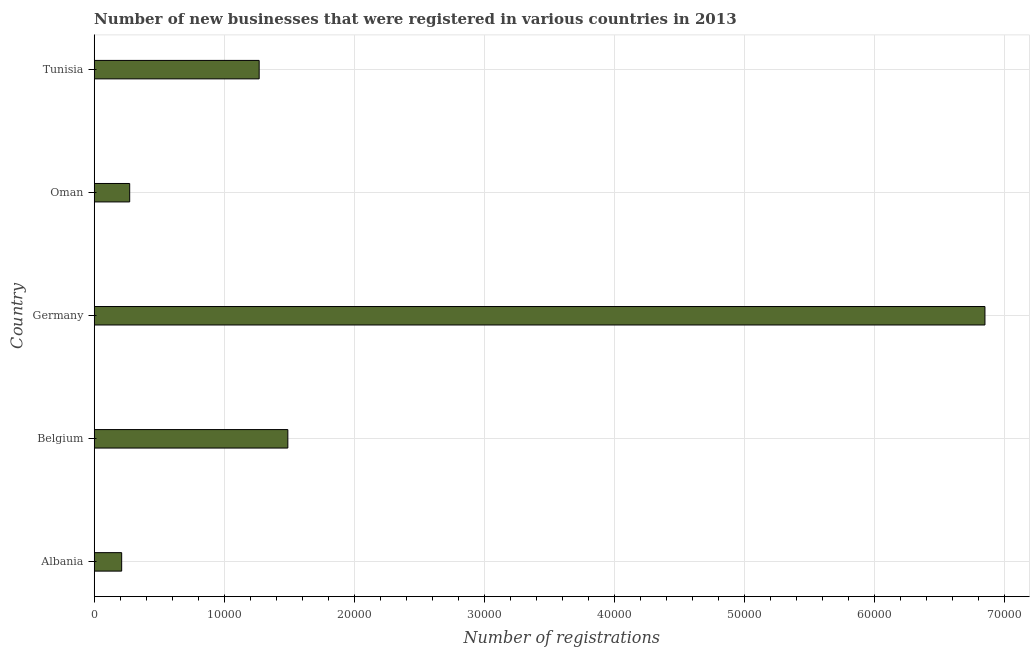What is the title of the graph?
Your answer should be very brief. Number of new businesses that were registered in various countries in 2013. What is the label or title of the X-axis?
Provide a short and direct response. Number of registrations. What is the label or title of the Y-axis?
Keep it short and to the point. Country. What is the number of new business registrations in Oman?
Give a very brief answer. 2730. Across all countries, what is the maximum number of new business registrations?
Offer a terse response. 6.85e+04. Across all countries, what is the minimum number of new business registrations?
Provide a short and direct response. 2114. In which country was the number of new business registrations maximum?
Provide a short and direct response. Germany. In which country was the number of new business registrations minimum?
Provide a succinct answer. Albania. What is the sum of the number of new business registrations?
Give a very brief answer. 1.01e+05. What is the difference between the number of new business registrations in Albania and Germany?
Make the answer very short. -6.64e+04. What is the average number of new business registrations per country?
Your response must be concise. 2.02e+04. What is the median number of new business registrations?
Make the answer very short. 1.27e+04. In how many countries, is the number of new business registrations greater than 66000 ?
Provide a short and direct response. 1. What is the ratio of the number of new business registrations in Albania to that in Germany?
Your answer should be very brief. 0.03. What is the difference between the highest and the second highest number of new business registrations?
Your response must be concise. 5.36e+04. Is the sum of the number of new business registrations in Albania and Germany greater than the maximum number of new business registrations across all countries?
Your response must be concise. Yes. What is the difference between the highest and the lowest number of new business registrations?
Offer a terse response. 6.64e+04. Are all the bars in the graph horizontal?
Your answer should be very brief. Yes. How many countries are there in the graph?
Provide a succinct answer. 5. What is the difference between two consecutive major ticks on the X-axis?
Keep it short and to the point. 10000. Are the values on the major ticks of X-axis written in scientific E-notation?
Provide a short and direct response. No. What is the Number of registrations in Albania?
Make the answer very short. 2114. What is the Number of registrations of Belgium?
Provide a short and direct response. 1.49e+04. What is the Number of registrations in Germany?
Make the answer very short. 6.85e+04. What is the Number of registrations in Oman?
Provide a succinct answer. 2730. What is the Number of registrations in Tunisia?
Offer a terse response. 1.27e+04. What is the difference between the Number of registrations in Albania and Belgium?
Keep it short and to the point. -1.28e+04. What is the difference between the Number of registrations in Albania and Germany?
Provide a succinct answer. -6.64e+04. What is the difference between the Number of registrations in Albania and Oman?
Make the answer very short. -616. What is the difference between the Number of registrations in Albania and Tunisia?
Your response must be concise. -1.06e+04. What is the difference between the Number of registrations in Belgium and Germany?
Make the answer very short. -5.36e+04. What is the difference between the Number of registrations in Belgium and Oman?
Provide a short and direct response. 1.22e+04. What is the difference between the Number of registrations in Belgium and Tunisia?
Your response must be concise. 2206. What is the difference between the Number of registrations in Germany and Oman?
Ensure brevity in your answer.  6.58e+04. What is the difference between the Number of registrations in Germany and Tunisia?
Make the answer very short. 5.58e+04. What is the difference between the Number of registrations in Oman and Tunisia?
Ensure brevity in your answer.  -9961. What is the ratio of the Number of registrations in Albania to that in Belgium?
Give a very brief answer. 0.14. What is the ratio of the Number of registrations in Albania to that in Germany?
Your answer should be very brief. 0.03. What is the ratio of the Number of registrations in Albania to that in Oman?
Offer a very short reply. 0.77. What is the ratio of the Number of registrations in Albania to that in Tunisia?
Make the answer very short. 0.17. What is the ratio of the Number of registrations in Belgium to that in Germany?
Your answer should be compact. 0.22. What is the ratio of the Number of registrations in Belgium to that in Oman?
Ensure brevity in your answer.  5.46. What is the ratio of the Number of registrations in Belgium to that in Tunisia?
Ensure brevity in your answer.  1.17. What is the ratio of the Number of registrations in Germany to that in Oman?
Ensure brevity in your answer.  25.1. What is the ratio of the Number of registrations in Oman to that in Tunisia?
Give a very brief answer. 0.21. 